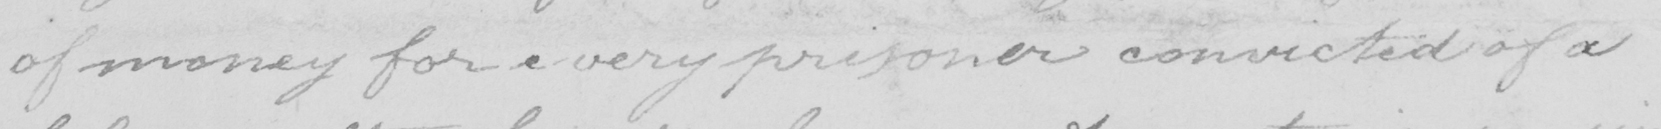What is written in this line of handwriting? of money for every prisoner convicted of a 